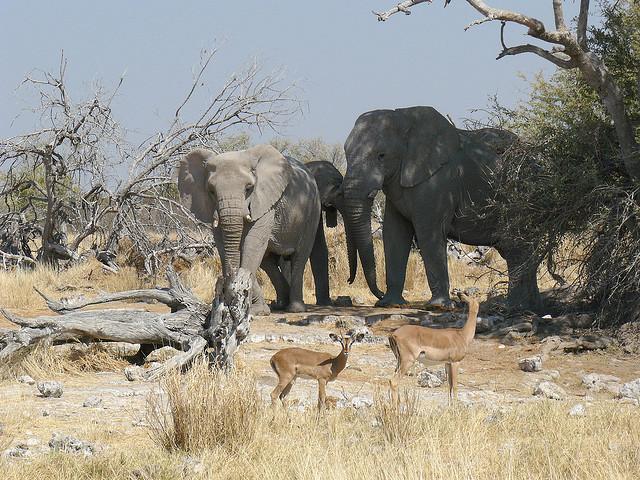What animal is in the photo?
Be succinct. Elephant. How many elephants are there?
Write a very short answer. 2. What kind of animals are these?
Be succinct. Elephants. How many elephants?
Write a very short answer. 2. What color are the deer?
Answer briefly. Brown. Where are the animals in the picture?
Write a very short answer. Yes. What are the animals?
Keep it brief. Elephants. What two types of animals  can you see here?
Short answer required. Elephants and deer. Are the animals spotted?
Quick response, please. No. Can all of these animals breed together?
Concise answer only. No. Do these animals eat the same kind of food?
Write a very short answer. Yes. 